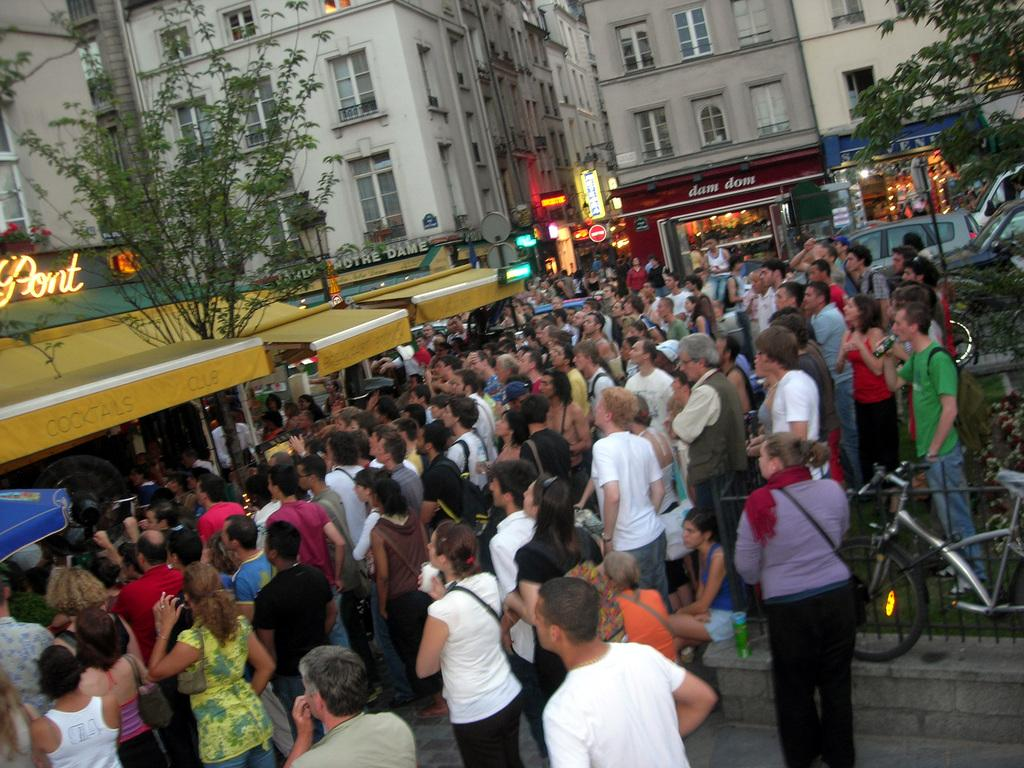What is located in the foreground of the image? There is a crowd and vehicles on the road in the foreground of the image. What can be seen in the background of the image? There are shops, buildings, trees, windows, and lights visible in the background of the image. What is the setting of the image? The image is taken on the road near shops. What type of music can be heard playing from the dock in the image? There is no dock or music present in the image. Is there a crown visible on anyone's head in the image? There is no crown visible on anyone's head in the image. 